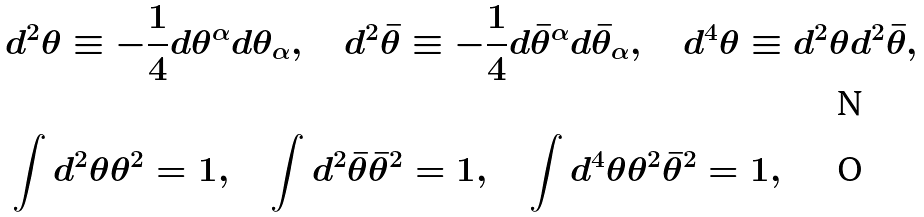Convert formula to latex. <formula><loc_0><loc_0><loc_500><loc_500>& d ^ { 2 } \theta \equiv - \frac { 1 } { 4 } d \theta ^ { \alpha } d \theta _ { \alpha } , \quad d ^ { 2 } \bar { \theta } \equiv - \frac { 1 } { 4 } d \bar { \theta } ^ { \alpha } d \bar { \theta } _ { \alpha } , \quad d ^ { 4 } \theta \equiv d ^ { 2 } \theta d ^ { 2 } \bar { \theta } , \\ & \int d ^ { 2 } \theta \theta ^ { 2 } = 1 , \quad \int d ^ { 2 } \bar { \theta } \bar { \theta } ^ { 2 } = 1 , \quad \int d ^ { 4 } \theta \theta ^ { 2 } \bar { \theta } ^ { 2 } = 1 ,</formula> 